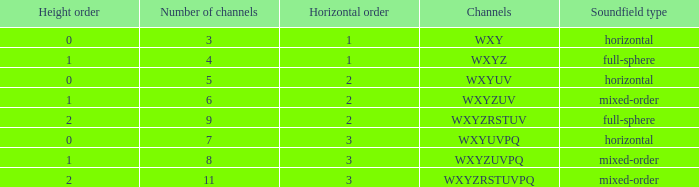If the height order is 1 and the soundfield type is mixed-order, what are all the channels? WXYZUV, WXYZUVPQ. 